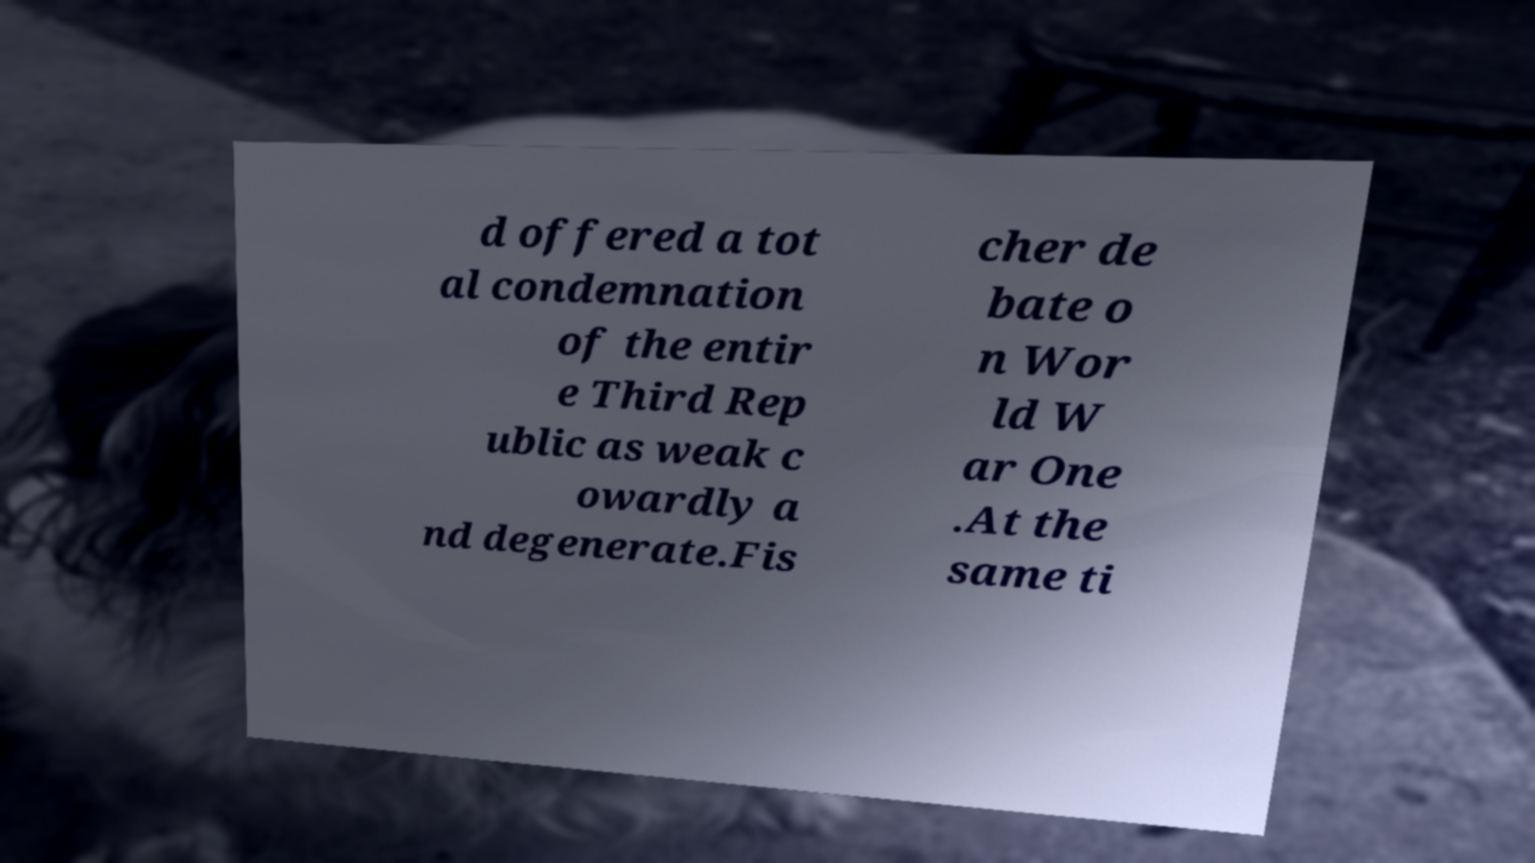Can you accurately transcribe the text from the provided image for me? d offered a tot al condemnation of the entir e Third Rep ublic as weak c owardly a nd degenerate.Fis cher de bate o n Wor ld W ar One .At the same ti 